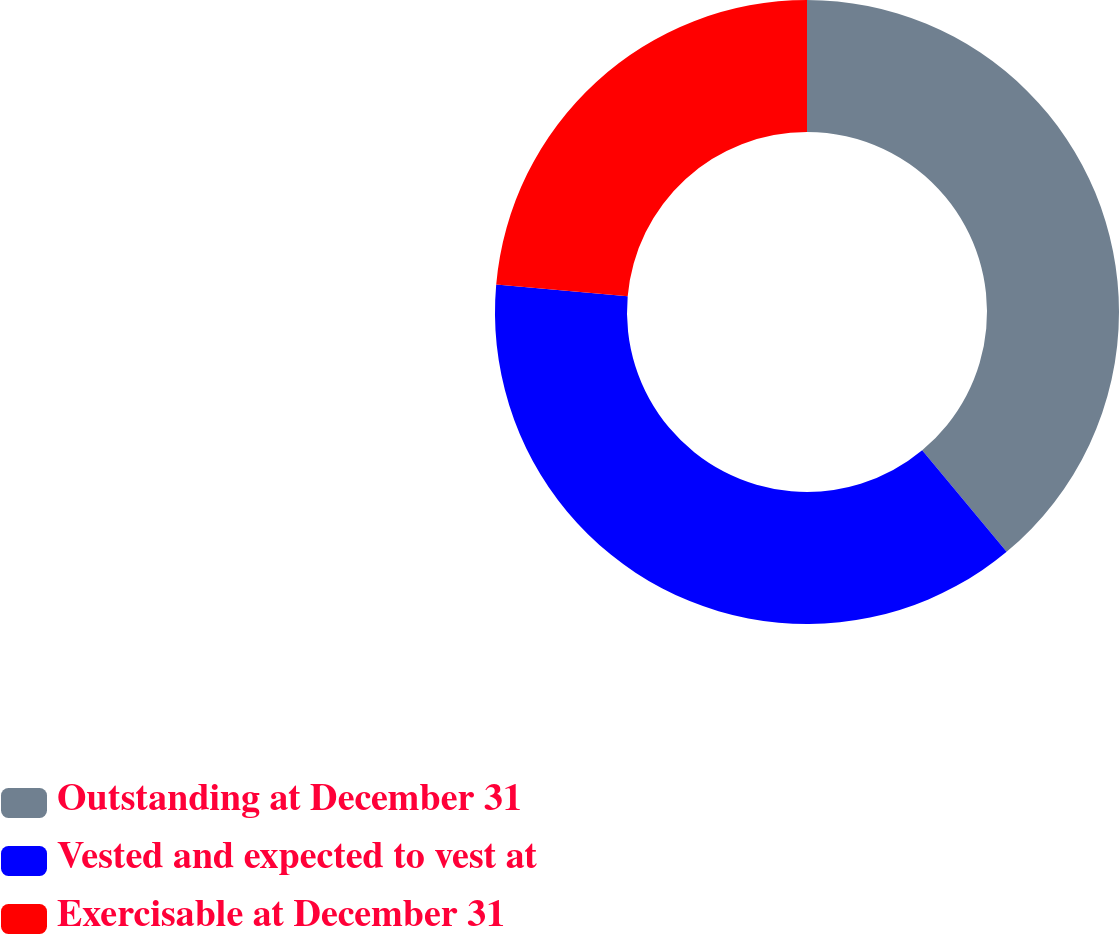Convert chart. <chart><loc_0><loc_0><loc_500><loc_500><pie_chart><fcel>Outstanding at December 31<fcel>Vested and expected to vest at<fcel>Exercisable at December 31<nl><fcel>38.95%<fcel>37.45%<fcel>23.6%<nl></chart> 